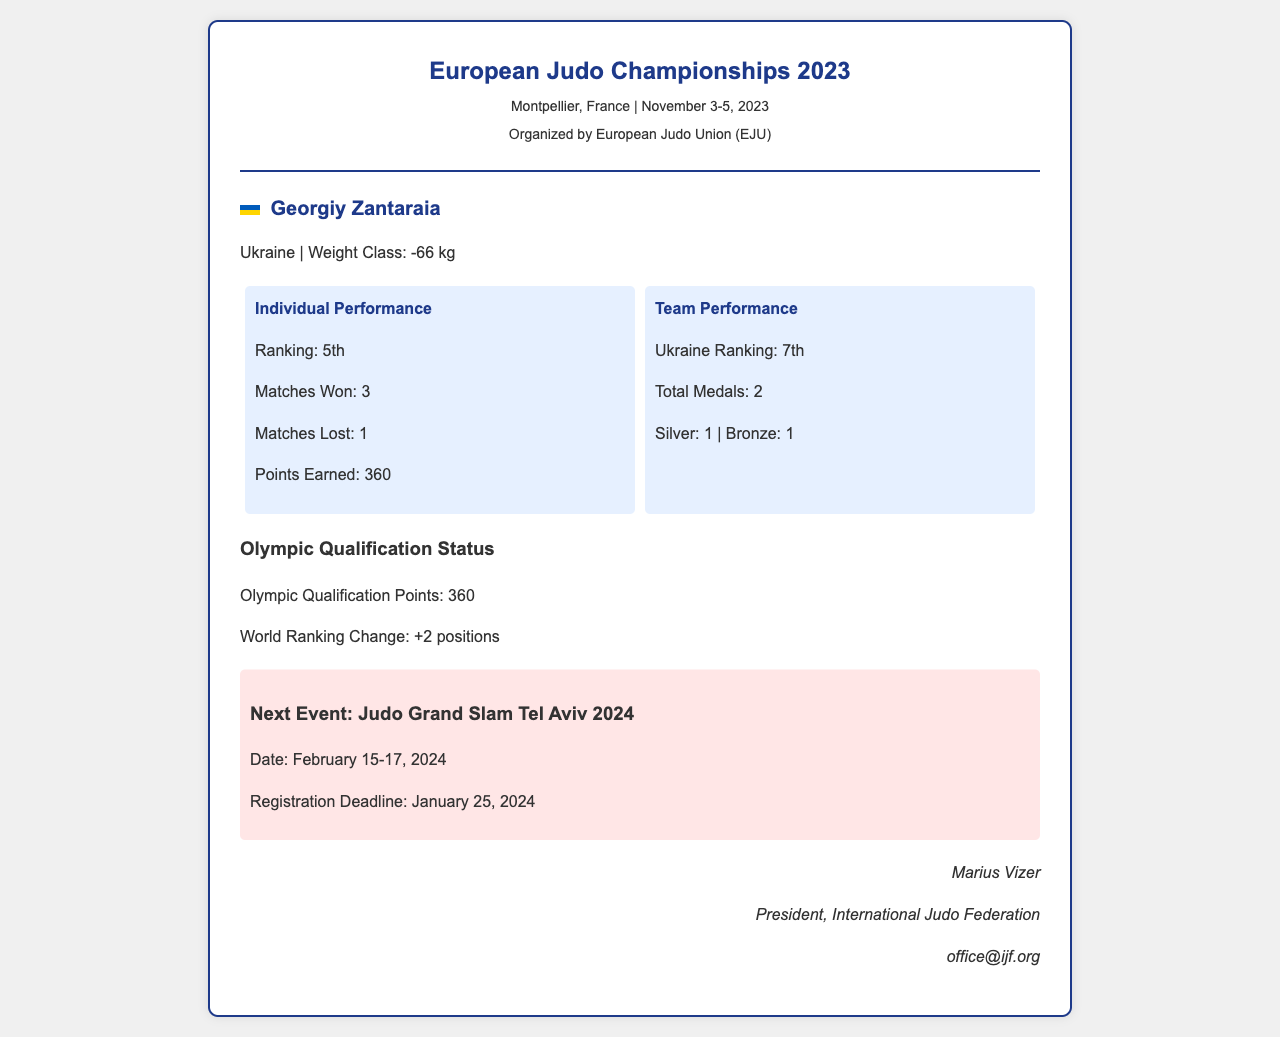What was Georgiy Zantaraia's ranking? The ranking of Georgiy Zantaraia is stated in the document under "Individual Performance."
Answer: 5th How many matches did Georgiy win? The number of matches won by Georgiy is found under "Individual Performance."
Answer: 3 What is the total number of medals won by the Ukrainian team? The total number of medals is provided under "Team Performance."
Answer: 2 What was the Ukraine team's ranking? The ranking of the Ukraine team is mentioned in the "Team Performance" section.
Answer: 7th What are the Olympic Qualification Points earned by Georgiy Zantaraia? The Olympic Qualification Points are specified in the "Olympic Qualification Status" section.
Answer: 360 What is the date for the next event? The date for the next event is included in the "Next Event" section of the document.
Answer: February 15-17, 2024 Who is the contact person mentioned in the document? The contact person is listed at the end of the document.
Answer: Marius Vizer What type of event is the next competition? The type of event is provided in the "Next Event" section.
Answer: Judo Grand Slam 